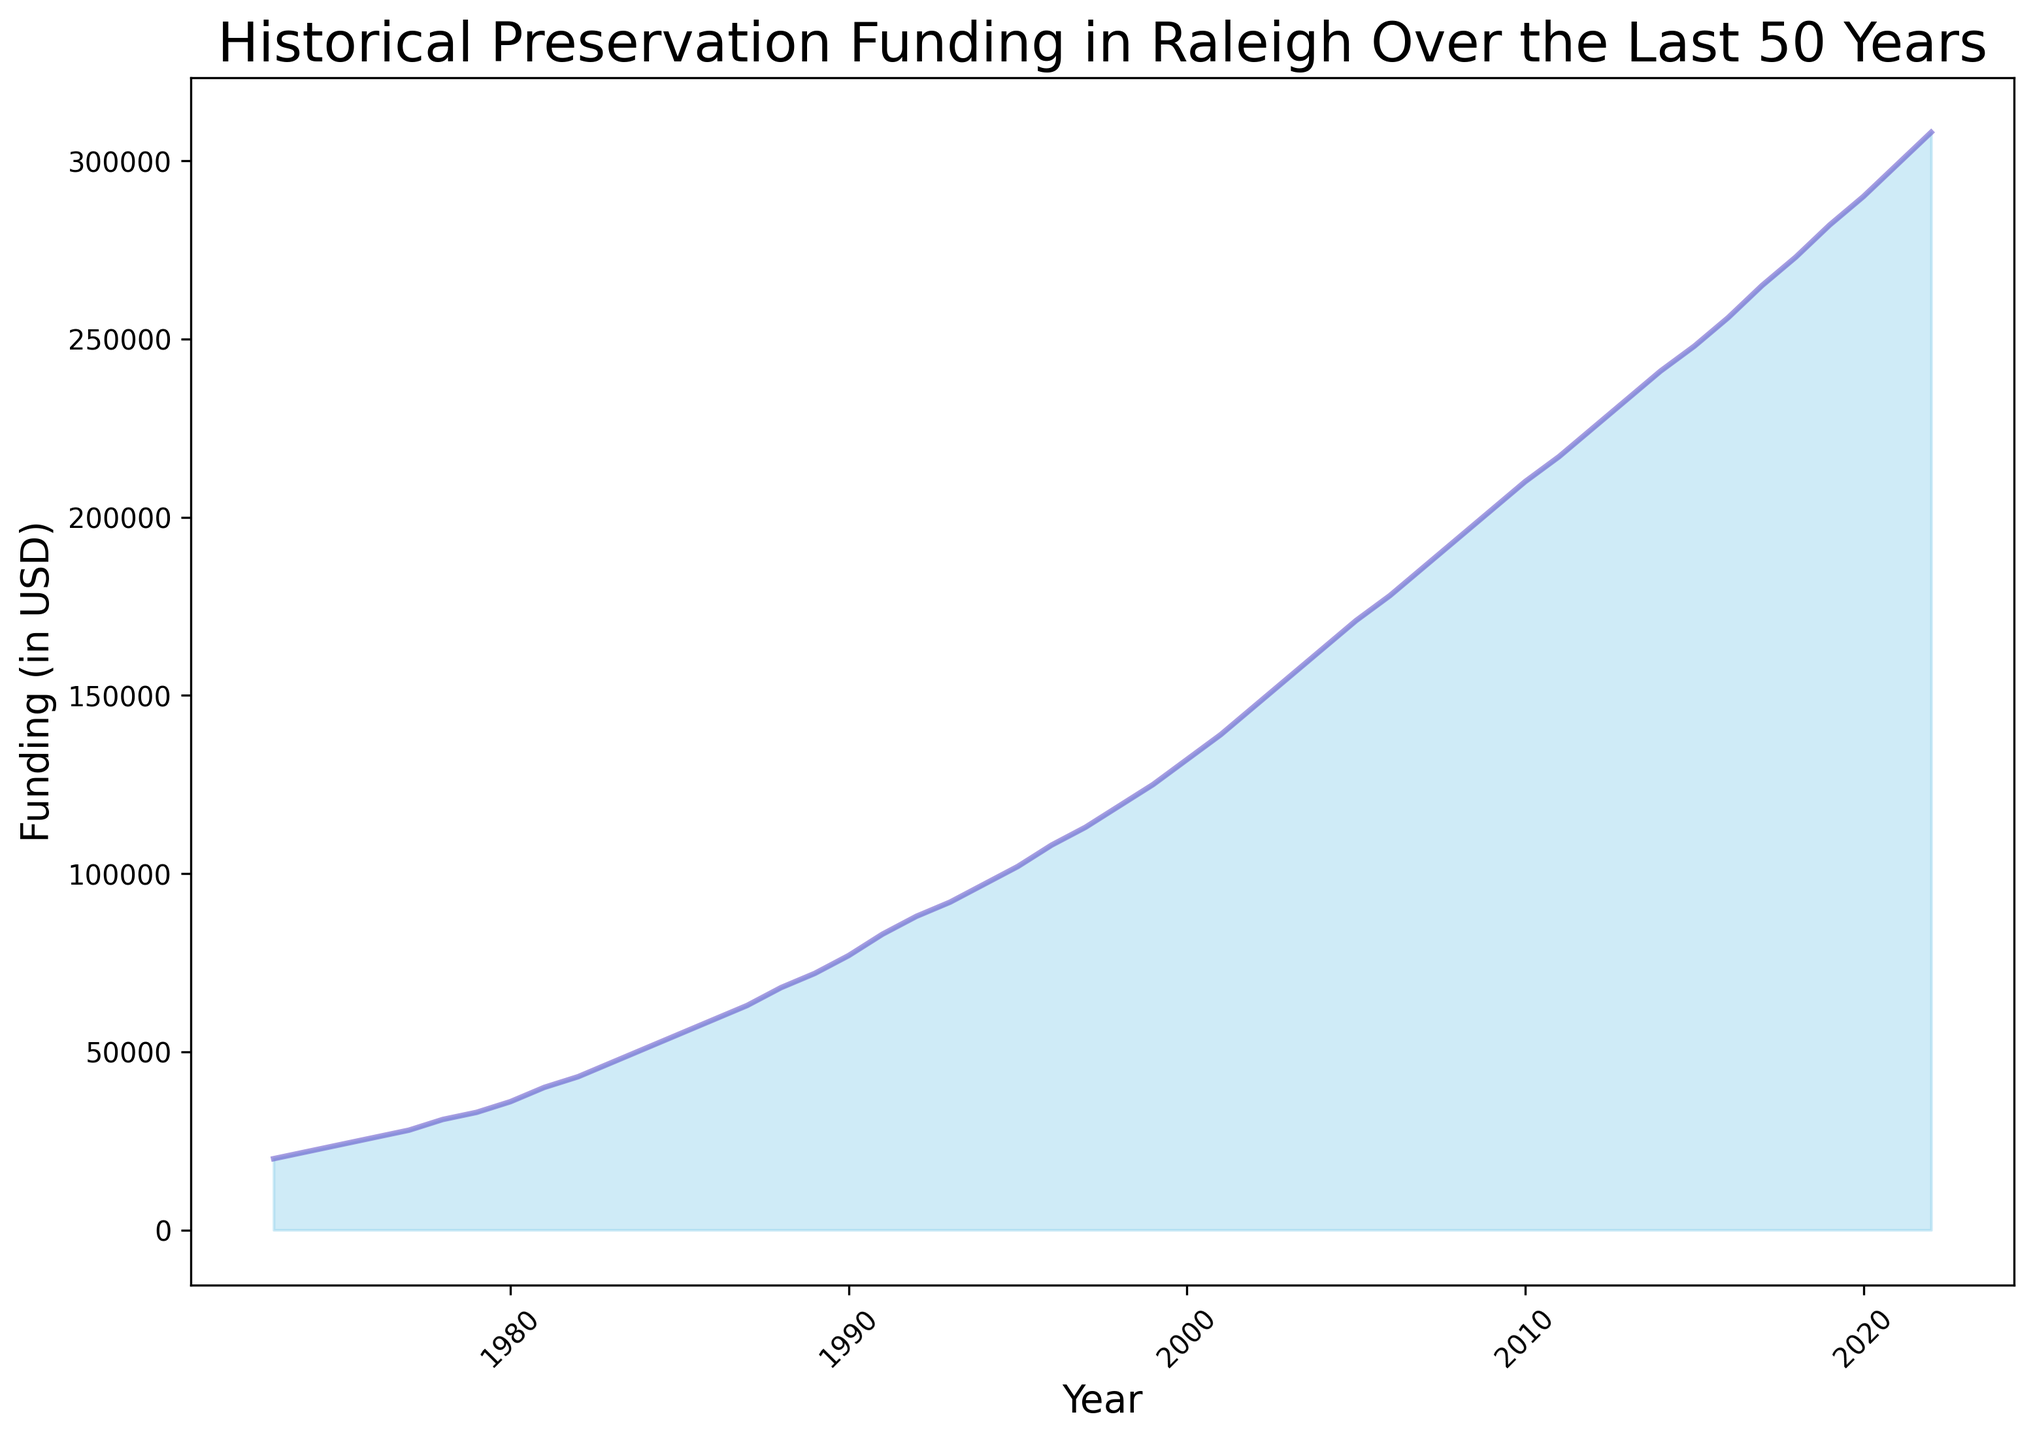What is the overall trend in historical preservation funding in Raleigh over the last 50 years? The figure shows a steady increase in historical preservation funding over the past 50 years, with funding starting at $20,000 in 1973 and rising to $308,000 in 2022. This indicates a consistent upward trend in funding levels.
Answer: Steady increase What is the percentage increase in funding from 1973 to 2022? Firstly, note the initial and final funding amounts: $20,000 in 1973 and $308,000 in 2022. The percentage increase is calculated as ((308,000 - 20,000) / 20,000) * 100. This yields ((288,000) / 20,000) * 100 = 1440%.
Answer: 1440% In which decade did the funding see the highest overall increase? Examining the figure, it shows that the decade with the highest increase appears to be between 2000 and 2010, where funding rises from approximately $132,000 to $210,000. This is an increase of $78,000, which is the highest decadal jump observed.
Answer: 2000 to 2010 How much funding was allocated in 1995 and how does it compare to 1985? From the figure, funding in 1995 was $102,000, and in 1985 it was $55,000. The difference between these years is $102,000 - $55,000 = $47,000, indicating that 1995 had $47,000 more funding than 1985.
Answer: $47,000 more in 1995 What was the average annual funding over this period? To calculate the average annual funding over 50 years, sum the funding values and divide by 50. With the given dataset, sum all funding amounts, then calculate the average. The sum is $5,880,000, so the average is $5,880,000 / 50 = $117,600.
Answer: $117,600 Is there any year where funding decreased compared to the previous year? By examining the figure, it is evident that the funding has consistently increased every year and there are no years where funding decreased compared to the previous year.
Answer: No In which year did the funding first reach above $100,000? Observing the figure shows that funding first crossed the $100,000 mark in 1994.
Answer: 1994 Between 2010 and 2015, what is the average annual increase in funding? From 2010 to 2015, funding increased from $210,000 to $248,000. The period here is 5 years. The total increase is $248,000 - $210,000 = $38,000. The average annual increase is $38,000 / 5 = $7,600.
Answer: $7,600 What does the area under the curve represent in the context of the chart? The area under the curve represents the cumulative amount of funding allocated to historical preservation in Raleigh over the last 50 years.
Answer: Cumulative funding Which year shows the highest funding, and what is its amount? The highest funding, as shown in the figure, is in the year 2022 with an amount of $308,000.
Answer: 2022 with $308,000 